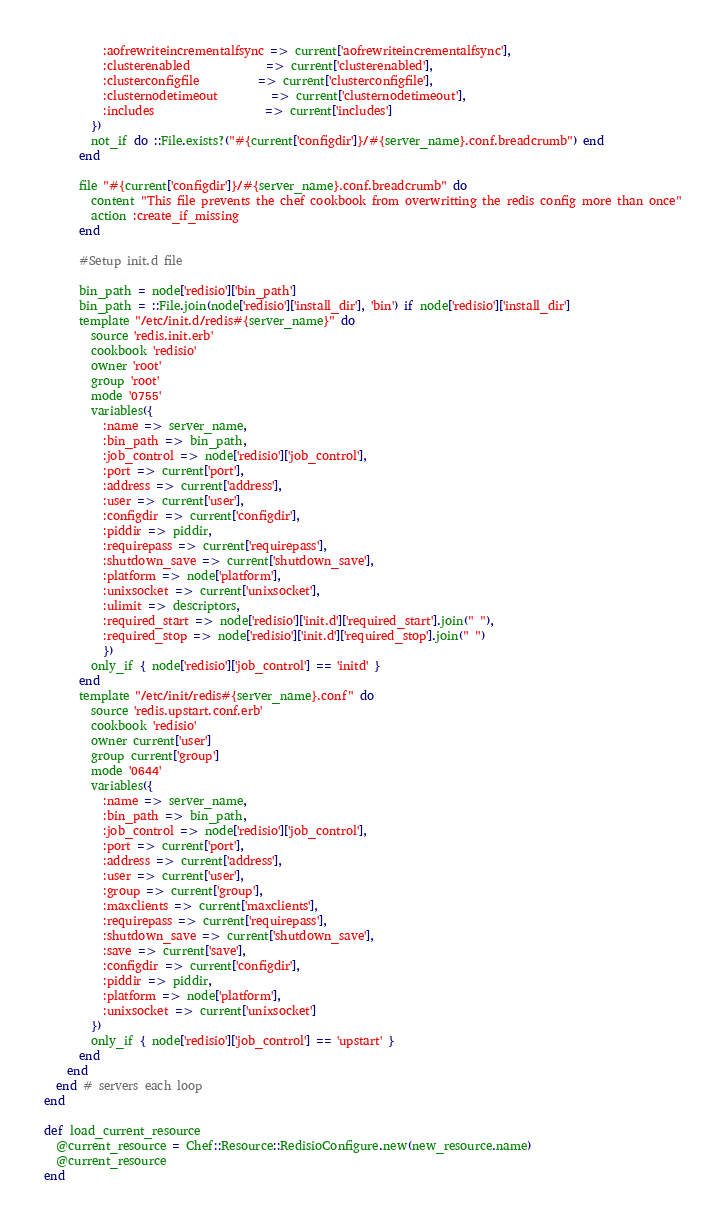<code> <loc_0><loc_0><loc_500><loc_500><_Ruby_>          :aofrewriteincrementalfsync => current['aofrewriteincrementalfsync'],
          :clusterenabled             => current['clusterenabled'],
          :clusterconfigfile          => current['clusterconfigfile'],
          :clusternodetimeout         => current['clusternodetimeout'],
          :includes                   => current['includes']
        })
        not_if do ::File.exists?("#{current['configdir']}/#{server_name}.conf.breadcrumb") end
      end

      file "#{current['configdir']}/#{server_name}.conf.breadcrumb" do
        content "This file prevents the chef cookbook from overwritting the redis config more than once"
        action :create_if_missing
      end

      #Setup init.d file

      bin_path = node['redisio']['bin_path']
      bin_path = ::File.join(node['redisio']['install_dir'], 'bin') if node['redisio']['install_dir']
      template "/etc/init.d/redis#{server_name}" do
        source 'redis.init.erb'
        cookbook 'redisio'
        owner 'root'
        group 'root'
        mode '0755'
        variables({
          :name => server_name,
          :bin_path => bin_path,
          :job_control => node['redisio']['job_control'],
          :port => current['port'],
          :address => current['address'],
          :user => current['user'],
          :configdir => current['configdir'],
          :piddir => piddir,
          :requirepass => current['requirepass'],
          :shutdown_save => current['shutdown_save'],
          :platform => node['platform'],
          :unixsocket => current['unixsocket'],
          :ulimit => descriptors,
          :required_start => node['redisio']['init.d']['required_start'].join(" "),
          :required_stop => node['redisio']['init.d']['required_stop'].join(" ")
          })
        only_if { node['redisio']['job_control'] == 'initd' }
      end
      template "/etc/init/redis#{server_name}.conf" do
        source 'redis.upstart.conf.erb'
        cookbook 'redisio'
        owner current['user']
        group current['group']
        mode '0644'
        variables({
          :name => server_name,
          :bin_path => bin_path,
          :job_control => node['redisio']['job_control'],
          :port => current['port'],
          :address => current['address'],
          :user => current['user'],
          :group => current['group'],
          :maxclients => current['maxclients'],
          :requirepass => current['requirepass'],
          :shutdown_save => current['shutdown_save'],
          :save => current['save'],
          :configdir => current['configdir'],
          :piddir => piddir,
          :platform => node['platform'],
          :unixsocket => current['unixsocket']
        })
        only_if { node['redisio']['job_control'] == 'upstart' }
      end
    end
  end # servers each loop
end

def load_current_resource
  @current_resource = Chef::Resource::RedisioConfigure.new(new_resource.name)
  @current_resource
end
</code> 